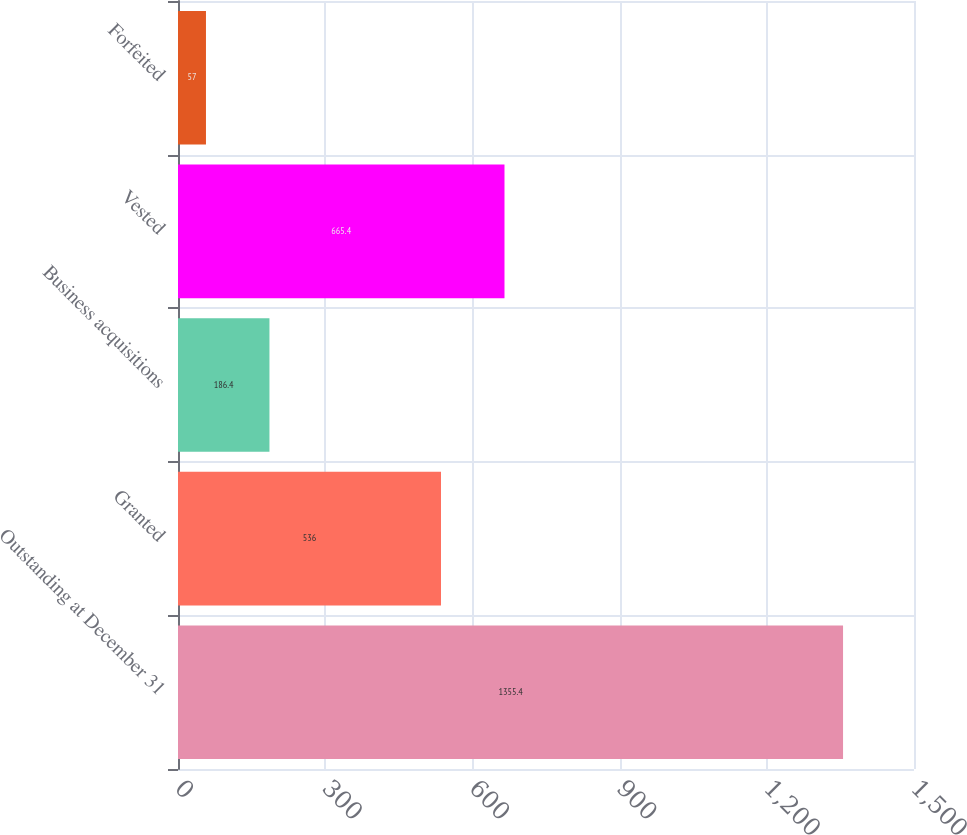<chart> <loc_0><loc_0><loc_500><loc_500><bar_chart><fcel>Outstanding at December 31<fcel>Granted<fcel>Business acquisitions<fcel>Vested<fcel>Forfeited<nl><fcel>1355.4<fcel>536<fcel>186.4<fcel>665.4<fcel>57<nl></chart> 